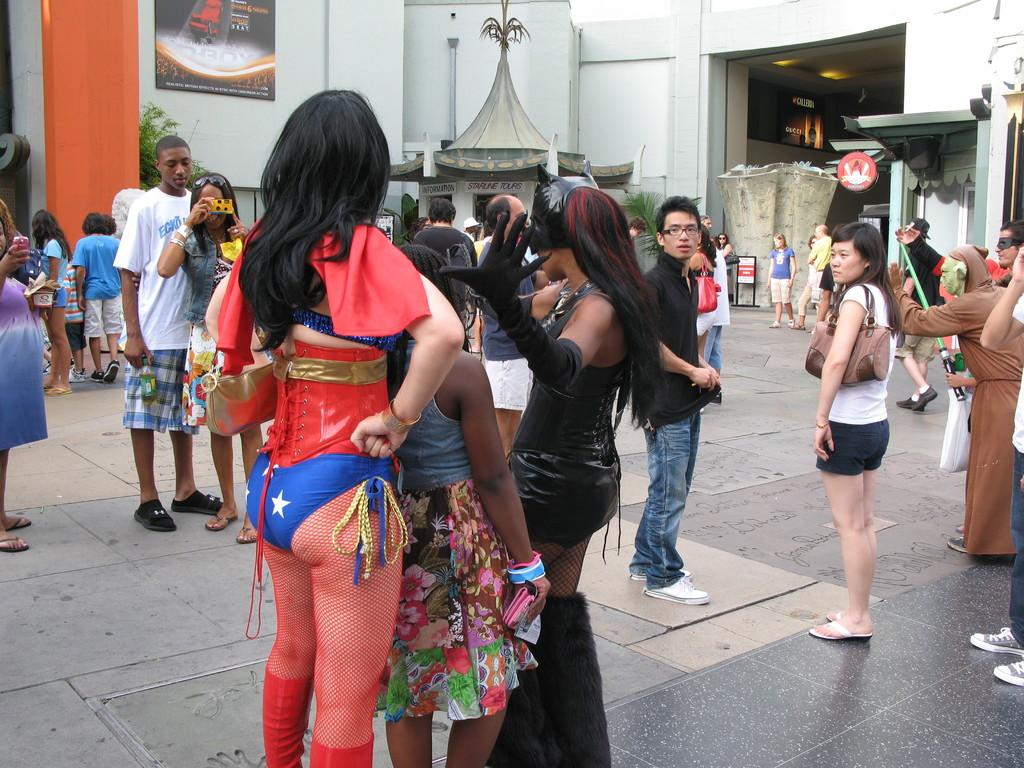What is the main subject of the image? There is a group of people in the middle of the image. What can be seen in the background of the image? There is a wall and a plant in the background of the image, along with other objects. Can you hear the bell ringing in the image? There is no bell present in the image, so it cannot be heard. Is there a boat visible in the image? There is no boat present in the image. 